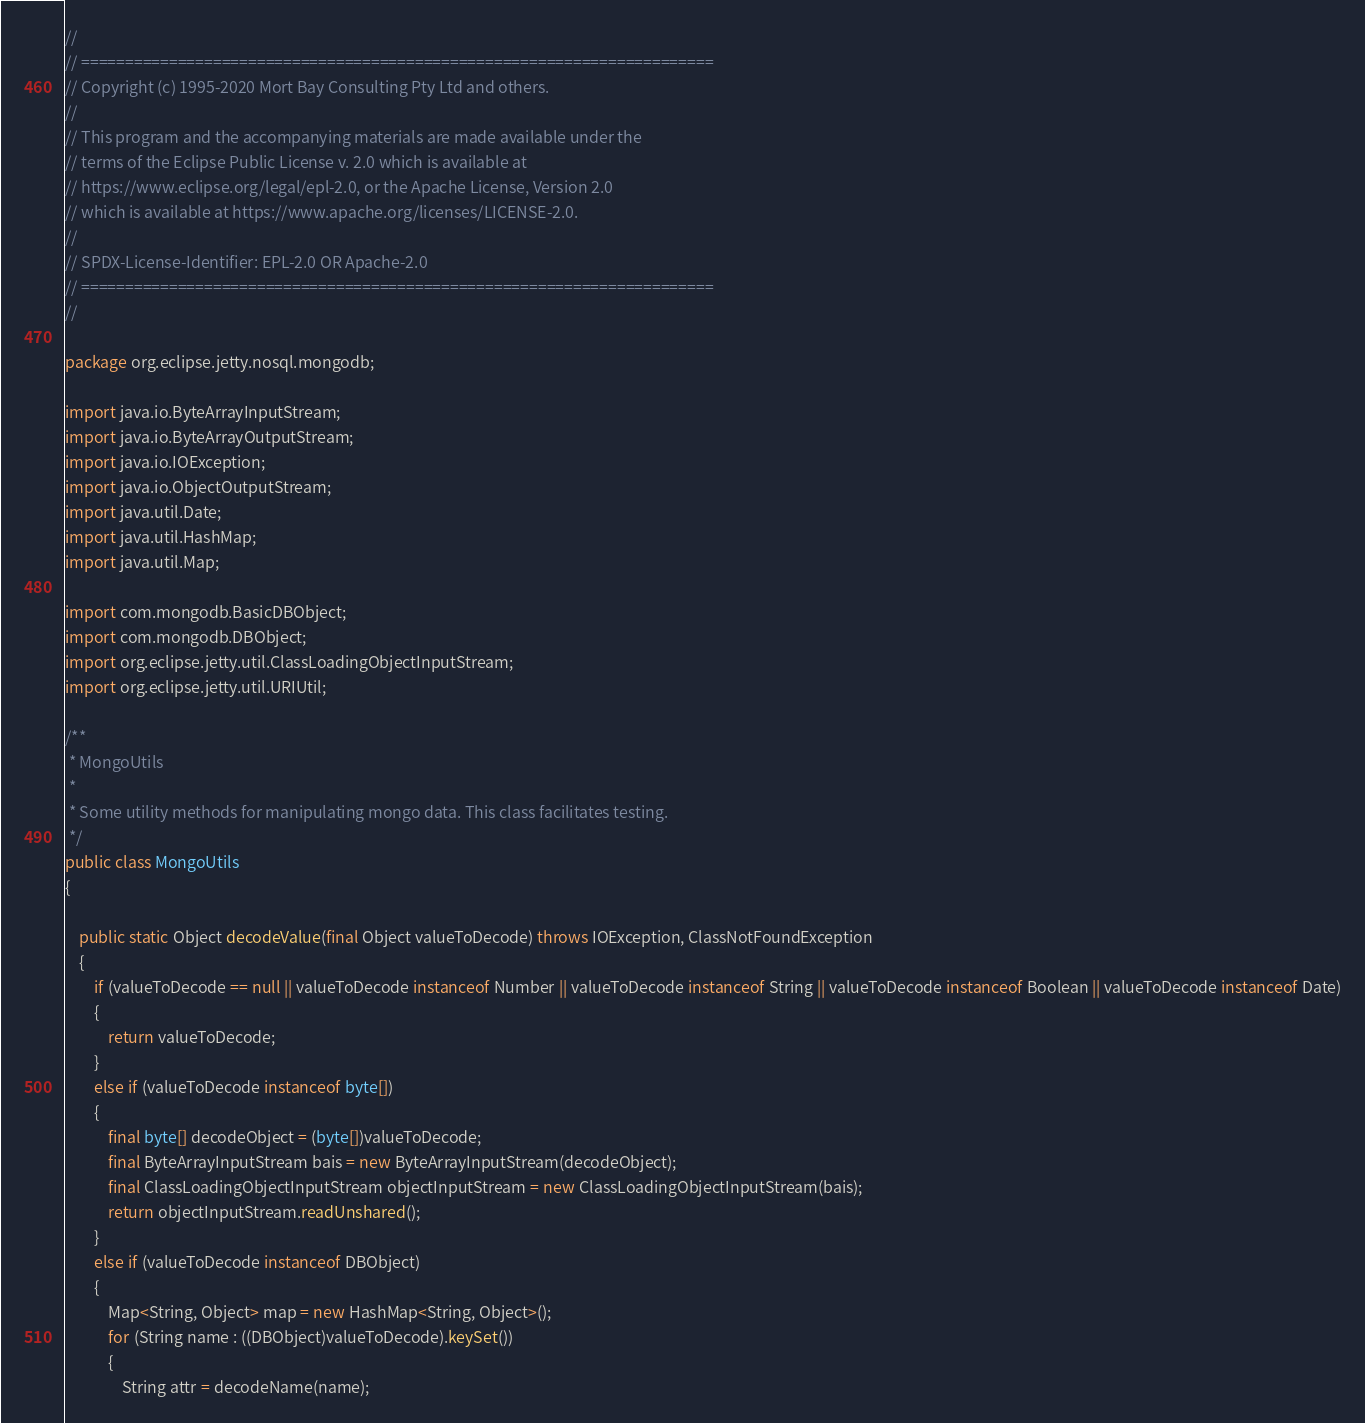<code> <loc_0><loc_0><loc_500><loc_500><_Java_>//
// ========================================================================
// Copyright (c) 1995-2020 Mort Bay Consulting Pty Ltd and others.
//
// This program and the accompanying materials are made available under the
// terms of the Eclipse Public License v. 2.0 which is available at
// https://www.eclipse.org/legal/epl-2.0, or the Apache License, Version 2.0
// which is available at https://www.apache.org/licenses/LICENSE-2.0.
//
// SPDX-License-Identifier: EPL-2.0 OR Apache-2.0
// ========================================================================
//

package org.eclipse.jetty.nosql.mongodb;

import java.io.ByteArrayInputStream;
import java.io.ByteArrayOutputStream;
import java.io.IOException;
import java.io.ObjectOutputStream;
import java.util.Date;
import java.util.HashMap;
import java.util.Map;

import com.mongodb.BasicDBObject;
import com.mongodb.DBObject;
import org.eclipse.jetty.util.ClassLoadingObjectInputStream;
import org.eclipse.jetty.util.URIUtil;

/**
 * MongoUtils
 *
 * Some utility methods for manipulating mongo data. This class facilitates testing.
 */
public class MongoUtils
{

    public static Object decodeValue(final Object valueToDecode) throws IOException, ClassNotFoundException
    {
        if (valueToDecode == null || valueToDecode instanceof Number || valueToDecode instanceof String || valueToDecode instanceof Boolean || valueToDecode instanceof Date)
        {
            return valueToDecode;
        }
        else if (valueToDecode instanceof byte[])
        {
            final byte[] decodeObject = (byte[])valueToDecode;
            final ByteArrayInputStream bais = new ByteArrayInputStream(decodeObject);
            final ClassLoadingObjectInputStream objectInputStream = new ClassLoadingObjectInputStream(bais);
            return objectInputStream.readUnshared();
        }
        else if (valueToDecode instanceof DBObject)
        {
            Map<String, Object> map = new HashMap<String, Object>();
            for (String name : ((DBObject)valueToDecode).keySet())
            {
                String attr = decodeName(name);</code> 